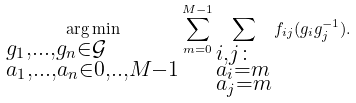<formula> <loc_0><loc_0><loc_500><loc_500>\underset { \begin{subarray} { c } g _ { 1 } , \dots , g _ { n } \in \mathcal { G } \\ a _ { 1 } , \dots , a _ { n } \in { 0 , . . , M - 1 } \end{subarray} } { \arg \min } \sum _ { m = 0 } ^ { M - 1 } \sum _ { \begin{subarray} { c } i , j \colon \\ a _ { i } = m \\ a _ { j } = m \end{subarray} } f _ { i j } ( g _ { i } g _ { j } ^ { - 1 } ) .</formula> 